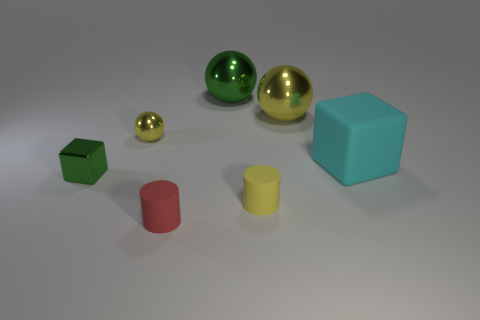Can you describe the material properties exhibited by the objects? Certainly! The spheres exhibit a highly reflective, glossy finish suggestive of polished metal or glass, while the cube and cylinders have a matte surface indicating a more diffuse, possibly plastic material. Which object looks the softest, and can you tell why? None of the objects in the image give a definite impression of softness; they all seem to be made of hard materials. However, if it's about relative softness, the matte textures of the cube and cylinders might imply a somewhat softer appearance compared to the highly reflective spheres. 